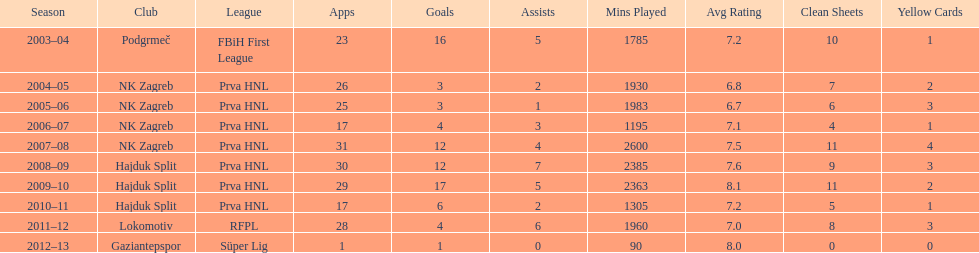What were the names of each club where more than 15 goals were scored in a single season? Podgrmeč, Hajduk Split. 